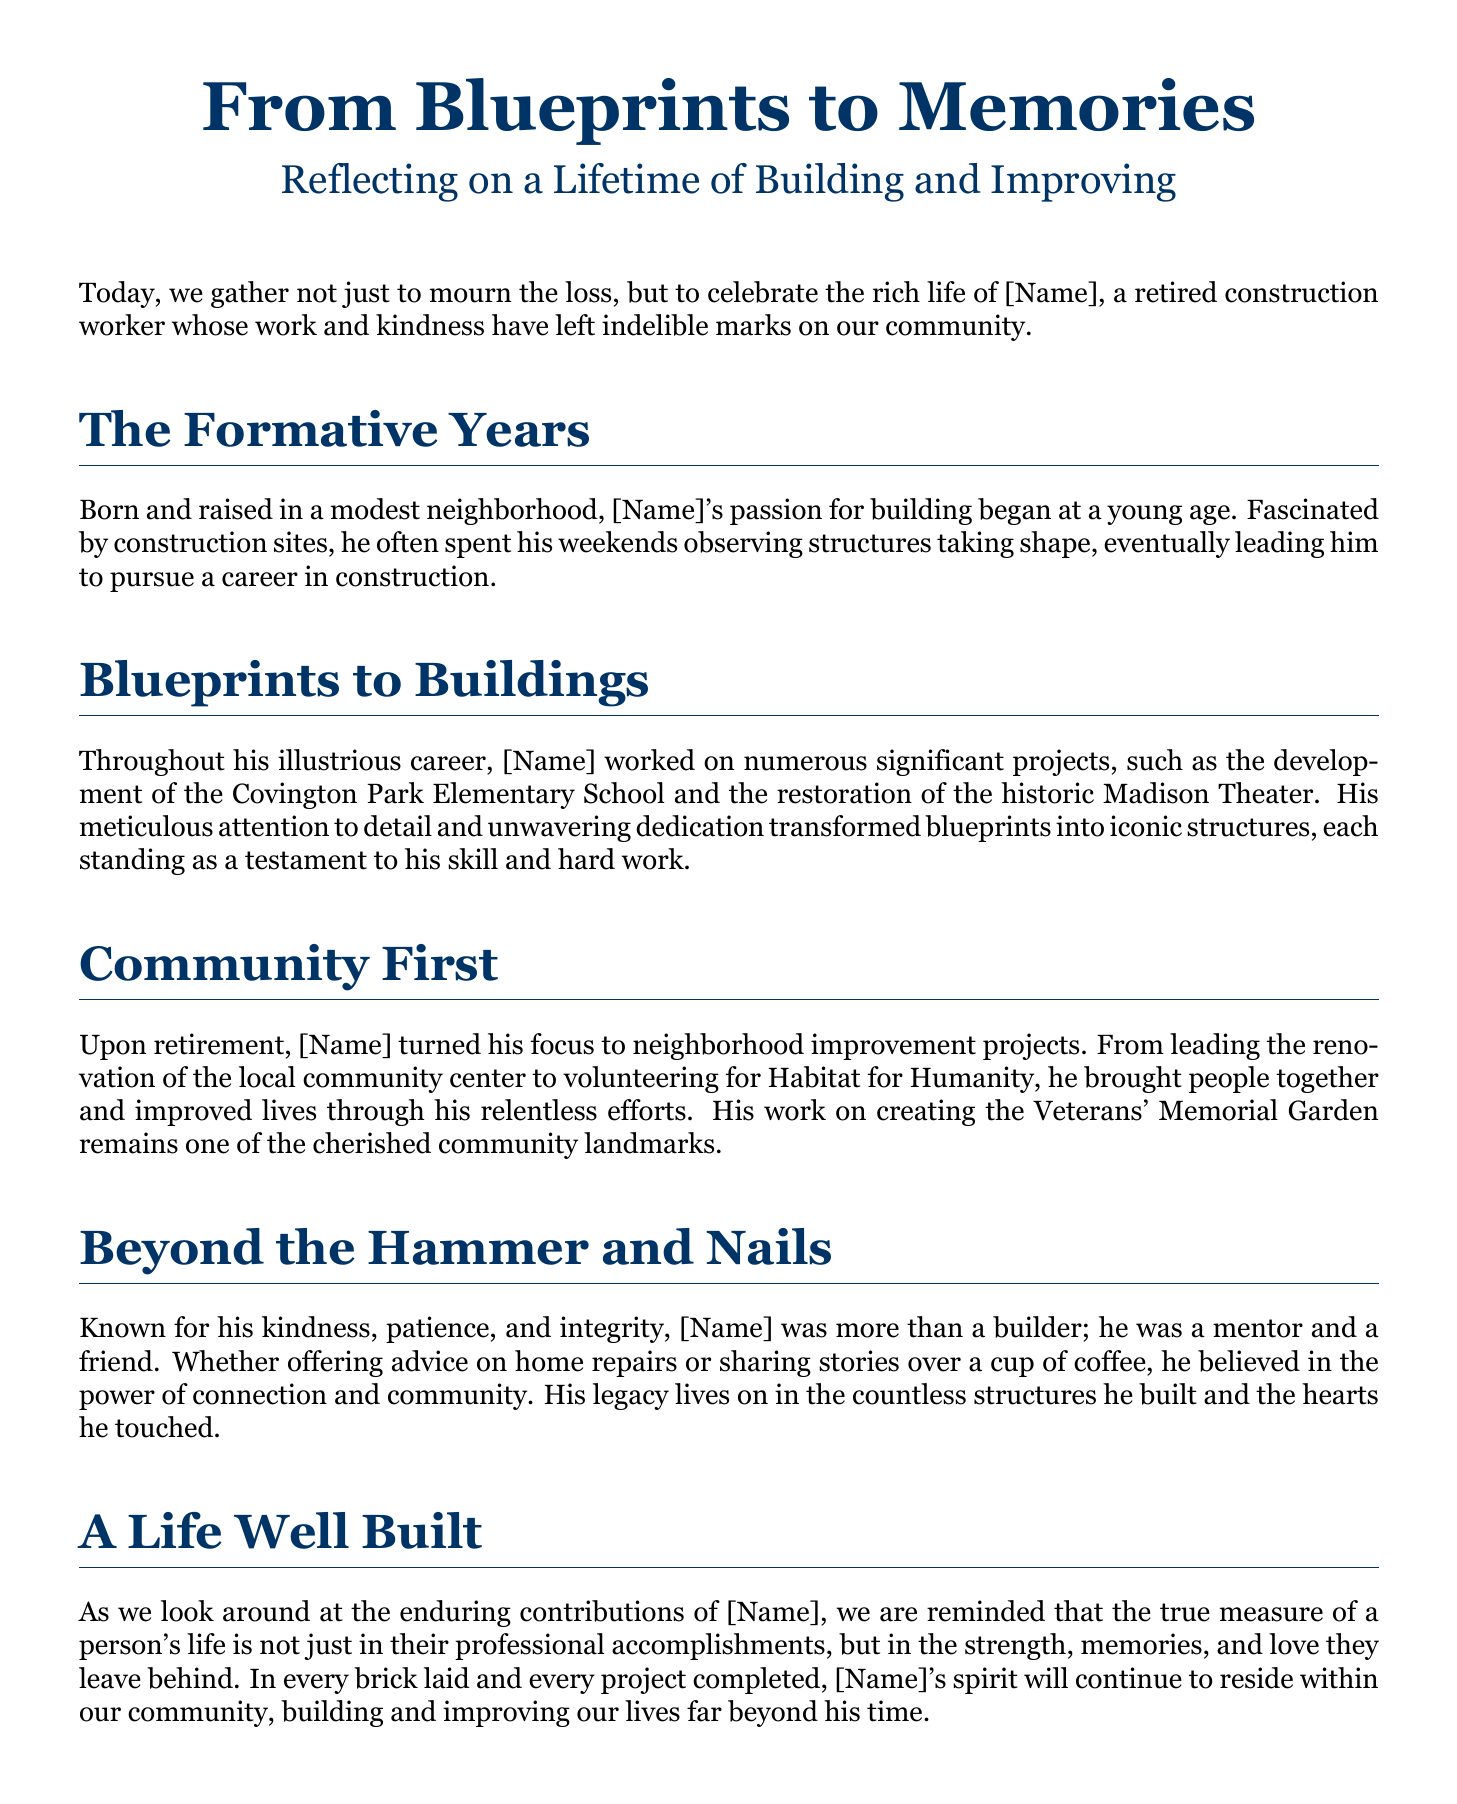What was [Name]'s profession? [Name] was a retired construction worker as stated in the introduction of the document.
Answer: construction worker What notable projects did [Name] work on? The document mentions the development of Covington Park Elementary School and the Madison Theater restoration as significant projects.
Answer: Covington Park Elementary School and Madison Theater Which community project did [Name] lead after retirement? The document names the renovation of the local community center as a project he led post-retirement.
Answer: local community center What is the name of the memorial garden [Name] worked on? The document refers to the Veterans' Memorial Garden as a significant community landmark he contributed to.
Answer: Veterans' Memorial Garden What qualities were attributed to [Name]? The document lists kindness, patience, and integrity as qualities that describe [Name].
Answer: kindness, patience, integrity How does the document define a person's true measure of life? The document suggests that a person's life is measured not just by professional accomplishments but by the memories and love they leave behind.
Answer: memories and love How did [Name] believe in building connections? The document states that [Name] believed in the power of connection and community through mentoring and sharing stories.
Answer: power of connection and community What type of contributions are highlighted in [Name]'s legacy? The enduring contributions of [Name] include both physical structures and the positive impact on people's lives, as noted in the conclusion.
Answer: physical structures and positive impact 